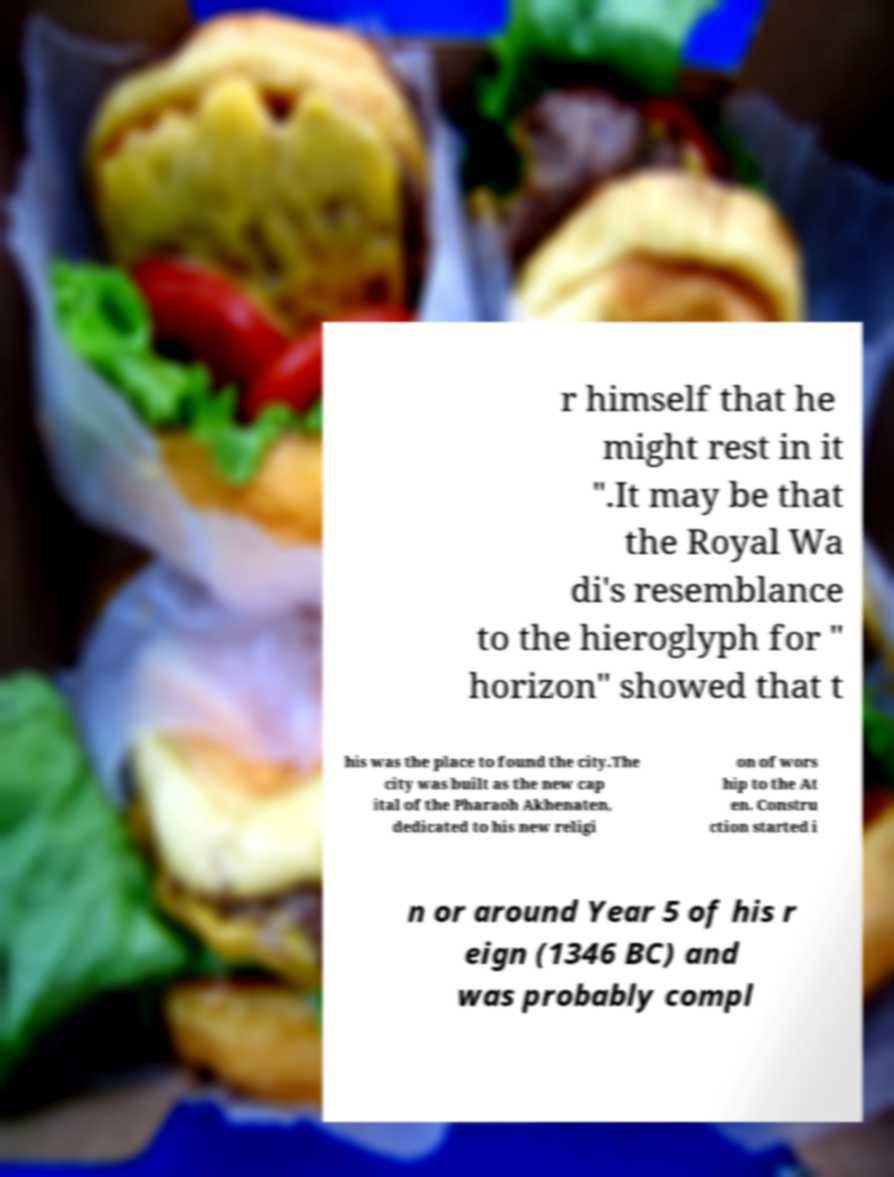I need the written content from this picture converted into text. Can you do that? r himself that he might rest in it ".It may be that the Royal Wa di's resemblance to the hieroglyph for " horizon" showed that t his was the place to found the city.The city was built as the new cap ital of the Pharaoh Akhenaten, dedicated to his new religi on of wors hip to the At en. Constru ction started i n or around Year 5 of his r eign (1346 BC) and was probably compl 